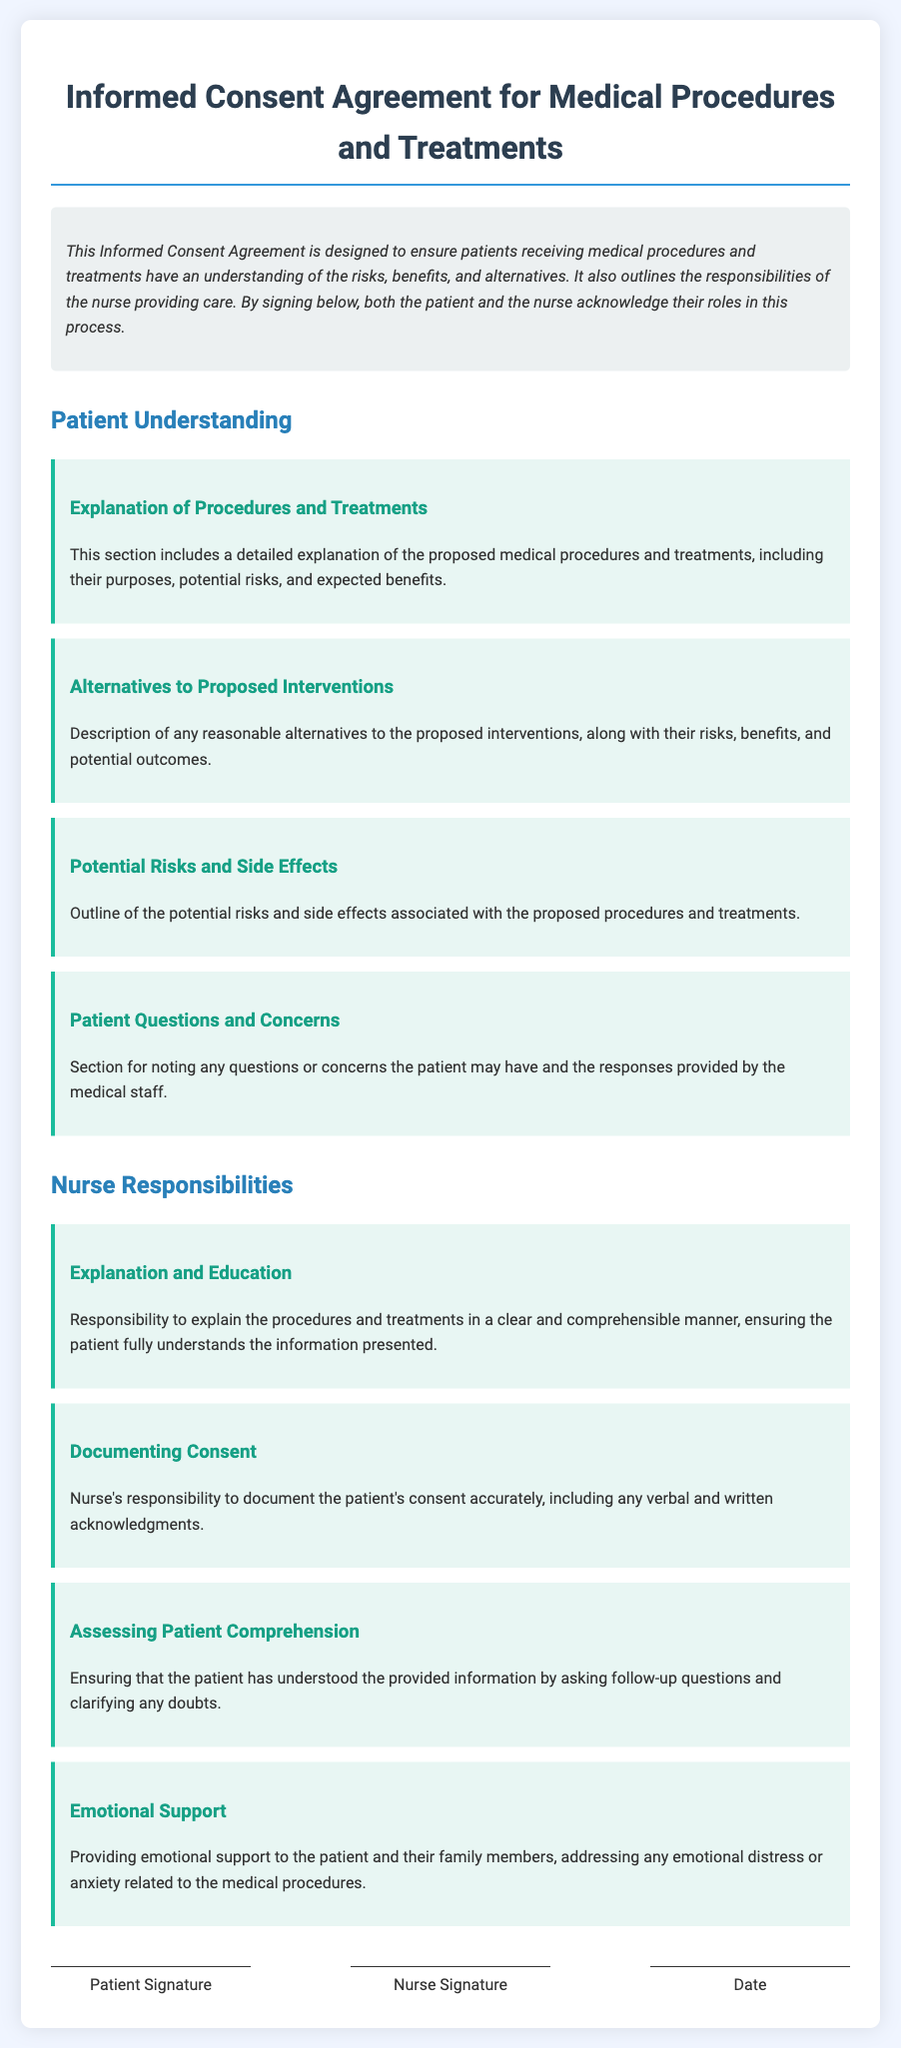What is the title of the document? The title is prominently displayed at the top of the document, stating the purpose of the agreement.
Answer: Informed Consent Agreement for Medical Procedures and Treatments What does the introduction highlight? The introduction provides a brief overview of the purpose and acknowledgment required from both parties regarding their roles.
Answer: Patient understanding and nurse responsibilities What section details the potential risks? The section outlines the risks associated with the medical procedures and treatments.
Answer: Potential Risks and Side Effects What is the nurse responsible for explaining? This responsibility includes ensuring that the patient understands the procedures clearly.
Answer: Explanation and Education What must the nurse document? The nurse has to accurately document the patient's consent.
Answer: Patient's consent How should the nurse assess comprehension? The nurse must clarify any doubts by asking follow-up questions.
Answer: Asking follow-up questions What kind of support must the nurse provide? The document specifies that the nurse should offer emotional assistance.
Answer: Emotional Support 